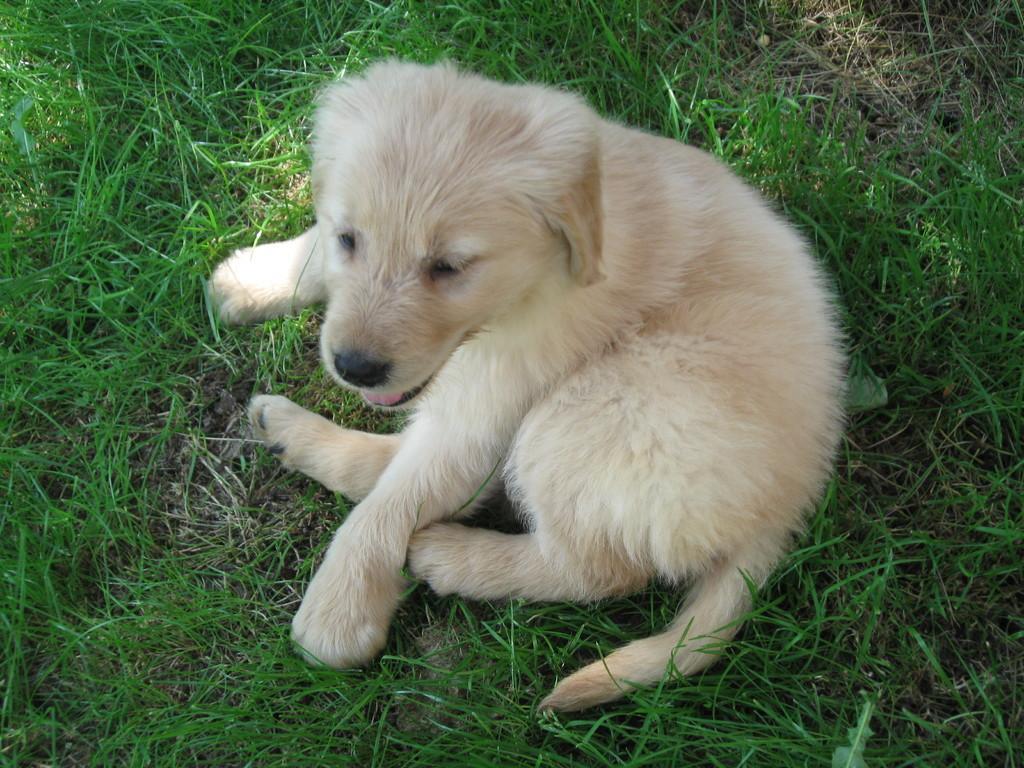Describe this image in one or two sentences. In the image there is a puppy laying on grass. 